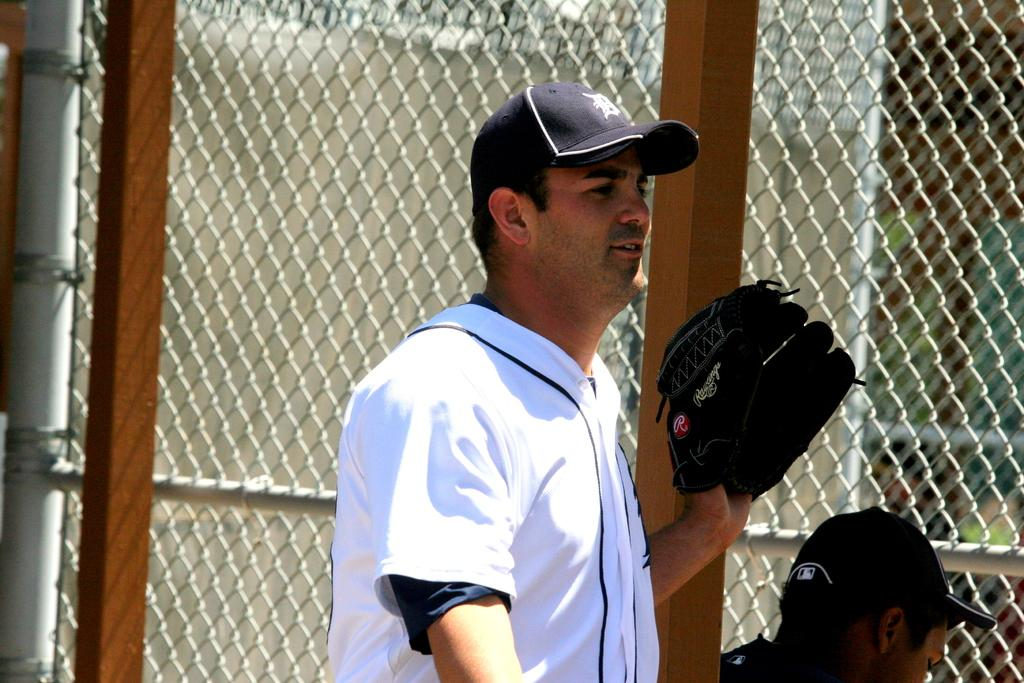What is the man in the image wearing on his upper body? The man is wearing a white t-shirt in the image. What type of headwear is the man wearing? The man is wearing a black cap in the image. Can you describe the position of the second man in relation to the first man? There is another man behind the first man in the image. What type of structure can be seen in the image? There is a fence, a pole, and a wall in the image. What other unspecified objects are present in the image? There are other unspecified objects in the image, but their details are not provided. Are there any boats visible in the image? No, there are no boats present in the image. 